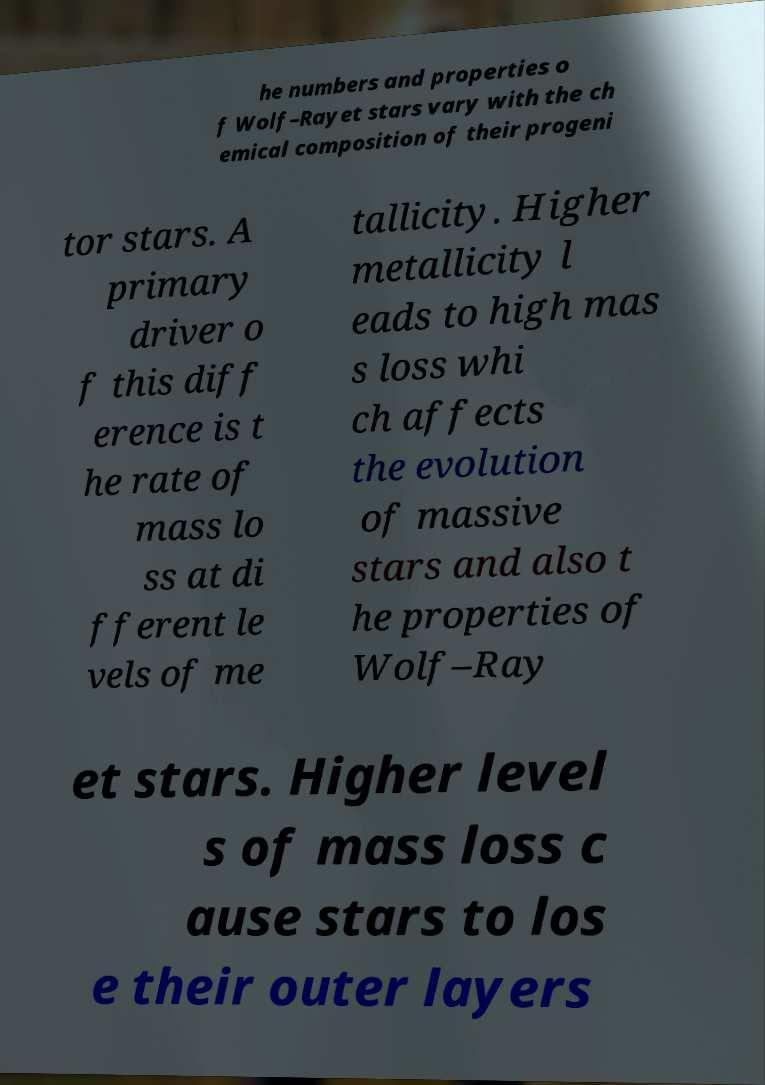What messages or text are displayed in this image? I need them in a readable, typed format. he numbers and properties o f Wolf–Rayet stars vary with the ch emical composition of their progeni tor stars. A primary driver o f this diff erence is t he rate of mass lo ss at di fferent le vels of me tallicity. Higher metallicity l eads to high mas s loss whi ch affects the evolution of massive stars and also t he properties of Wolf–Ray et stars. Higher level s of mass loss c ause stars to los e their outer layers 